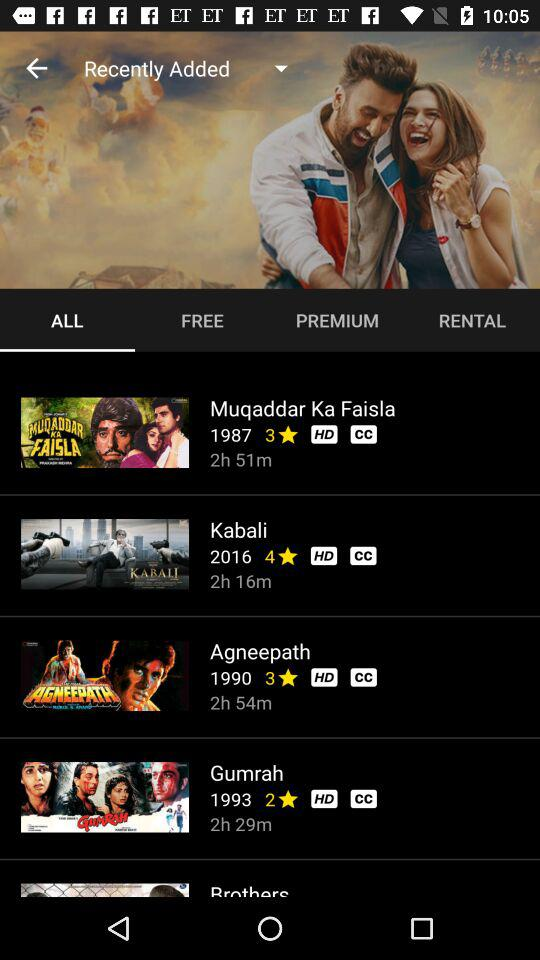What is the rating of the film "Agneepath"? The rating of the film is 3 stars. 